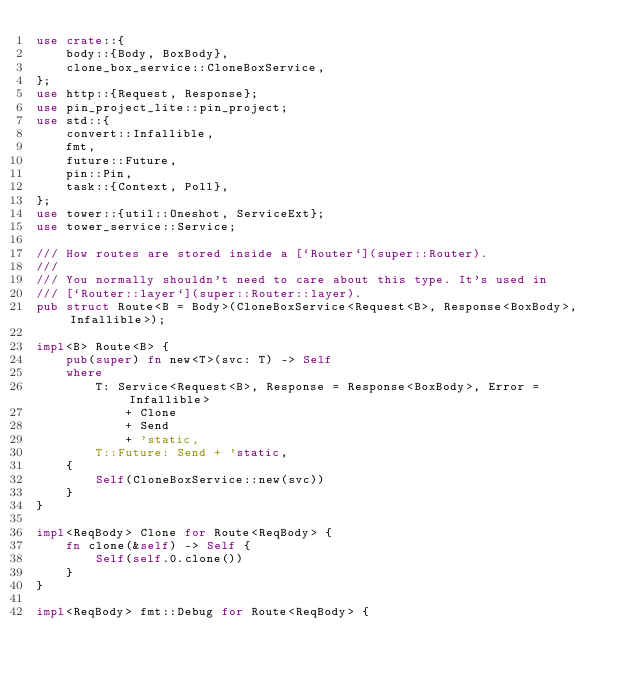<code> <loc_0><loc_0><loc_500><loc_500><_Rust_>use crate::{
    body::{Body, BoxBody},
    clone_box_service::CloneBoxService,
};
use http::{Request, Response};
use pin_project_lite::pin_project;
use std::{
    convert::Infallible,
    fmt,
    future::Future,
    pin::Pin,
    task::{Context, Poll},
};
use tower::{util::Oneshot, ServiceExt};
use tower_service::Service;

/// How routes are stored inside a [`Router`](super::Router).
///
/// You normally shouldn't need to care about this type. It's used in
/// [`Router::layer`](super::Router::layer).
pub struct Route<B = Body>(CloneBoxService<Request<B>, Response<BoxBody>, Infallible>);

impl<B> Route<B> {
    pub(super) fn new<T>(svc: T) -> Self
    where
        T: Service<Request<B>, Response = Response<BoxBody>, Error = Infallible>
            + Clone
            + Send
            + 'static,
        T::Future: Send + 'static,
    {
        Self(CloneBoxService::new(svc))
    }
}

impl<ReqBody> Clone for Route<ReqBody> {
    fn clone(&self) -> Self {
        Self(self.0.clone())
    }
}

impl<ReqBody> fmt::Debug for Route<ReqBody> {</code> 